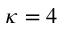Convert formula to latex. <formula><loc_0><loc_0><loc_500><loc_500>\kappa = 4</formula> 